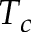<formula> <loc_0><loc_0><loc_500><loc_500>T _ { c }</formula> 